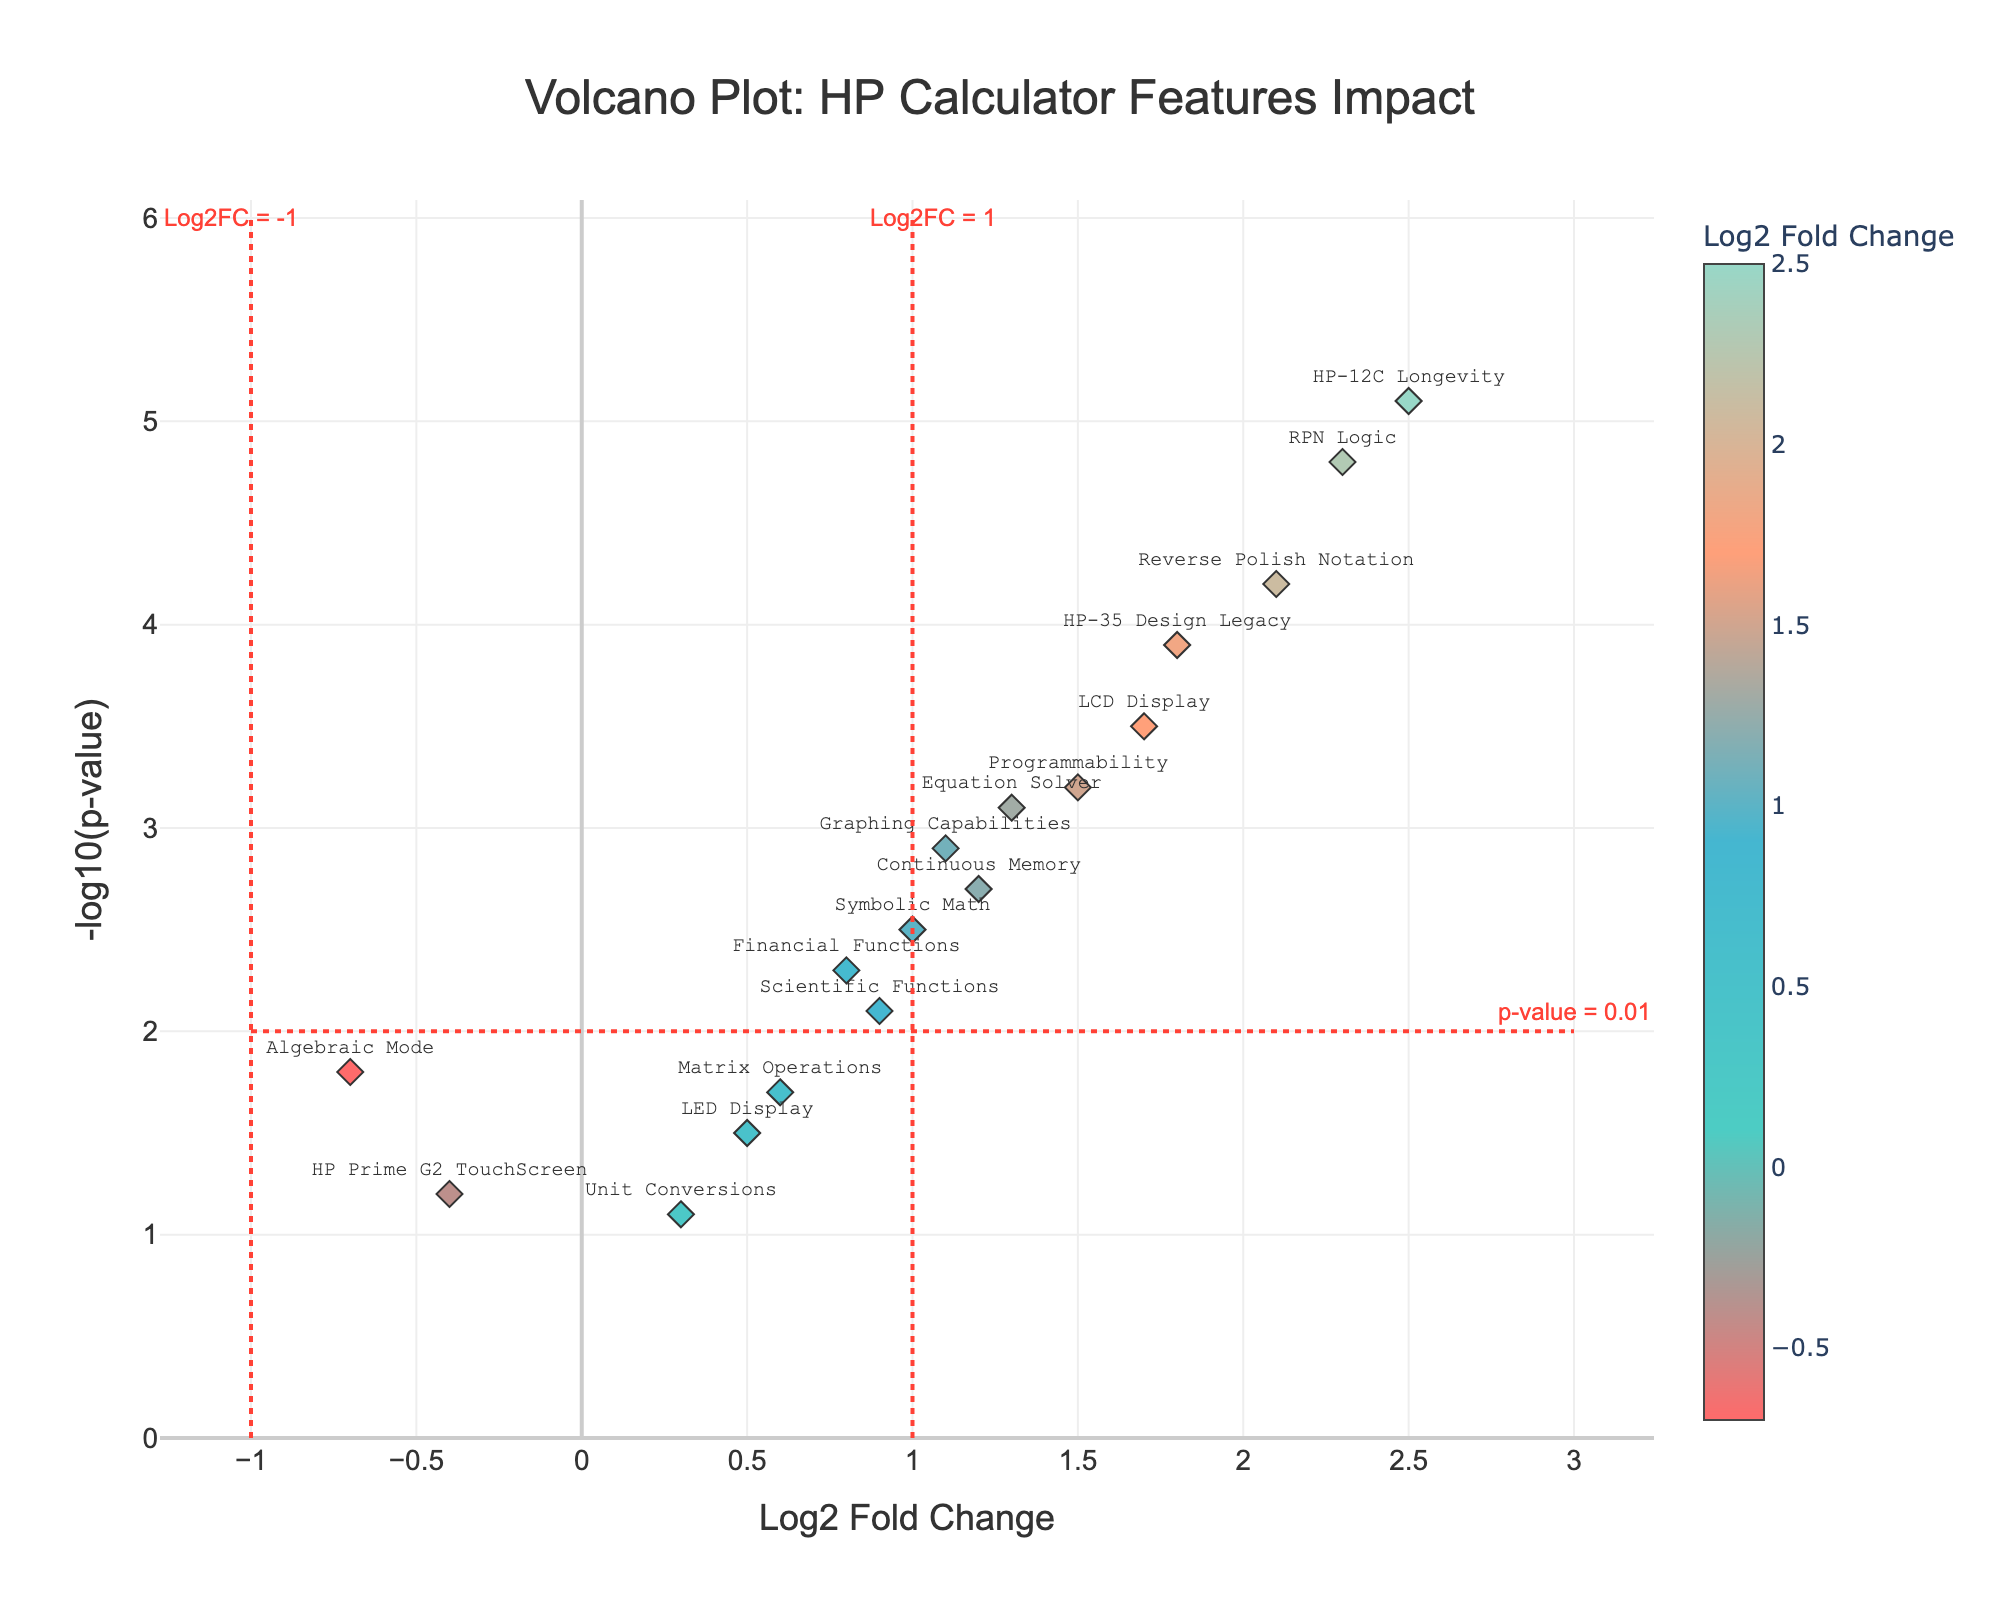Which feature has the highest significance in terms of market popularity? The most significant feature on the y-axis has the highest -log10(p-value). The highest point on the y-axis is at 5.1 for "HP-12C Longevity".
Answer: HP-12C Longevity Which feature has the highest positive impact on user adoption rates? The most positive impact is shown by the highest value on the x-axis (Log2 Fold Change). "HP-12C Longevity" has the highest Log2FC at 2.5.
Answer: HP-12C Longevity How many features have a negative Log2 Fold Change? A negative Log2 Fold Change indicates a point left of the origin (0) on the x-axis. There are two such points: "Algebraic Mode" (-0.7) and "HP Prime G2 TouchScreen" (-0.4).
Answer: 2 What value of Log2 Fold Change marks the threshold for significance in this plot? The plot has a vertical line marking the threshold at Log2 Fold Change = 1.
Answer: 1 What is the Log2 Fold Change and -log10(p-value) for Reverse Polish Notation? Locate "Reverse Polish Notation" on the plot. It has coordinates: Log2 Fold Change = 2.1, -log10(p-value) = 4.2.
Answer: 2.1, 4.2 Compare the significance of Programmability and Scientific Functions. Which one is more significant? Significance is determined by the y-axis value (-log10(p-value)). "Programmability" has 3.2, while "Scientific Functions" has 2.1; thus, Programmability is more significant.
Answer: Programmability Which feature has the lowest -log10(p-value) and what does it imply? The lowest -log10(p-value) is for "Unit Conversions" at 1.1. This implies Unit Conversions has the least statistical significance among the features.
Answer: Unit Conversions What does the horizontal red dashed line on the plot represent? The horizontal line is a threshold for p-value significance, commonly p-value = 0.01, marked as -log10(p-value) = 2.
Answer: p-value = 0.01 How do the Log2 Fold Change values for the display types (LED and LCD) compare? For "LED Display", Log2 Fold Change is 0.5. For "LCD Display", it is 1.7. The LCD Display has a higher Log2 Fold Change, indicating a greater impact on user adoption rates.
Answer: LCD Display > LED Display Which features fall below the Log2 Fold Change = 1 threshold but are significant according to the -log10(p-value) = 2 threshold? Look for points with Log2 Fold Change < 1 and -log10(p-value) > 2. These are "Scientific Functions" (0.9, 2.1) and "Financial Functions" (0.8, 2.3).
Answer: Scientific Functions, Financial Functions 